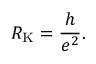Convert formula to latex. <formula><loc_0><loc_0><loc_500><loc_500>R _ { K } = { \frac { h } { e ^ { 2 } } } .</formula> 